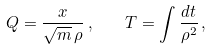Convert formula to latex. <formula><loc_0><loc_0><loc_500><loc_500>Q = \frac { x } { \sqrt { m } \, \rho } \, , \quad T = \int \frac { d t } { \rho ^ { 2 } } \, ,</formula> 